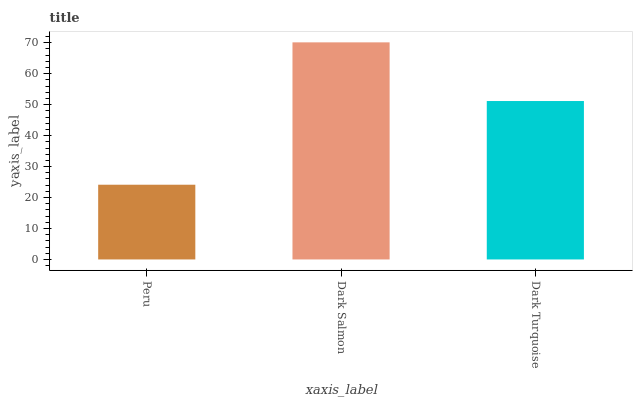Is Peru the minimum?
Answer yes or no. Yes. Is Dark Salmon the maximum?
Answer yes or no. Yes. Is Dark Turquoise the minimum?
Answer yes or no. No. Is Dark Turquoise the maximum?
Answer yes or no. No. Is Dark Salmon greater than Dark Turquoise?
Answer yes or no. Yes. Is Dark Turquoise less than Dark Salmon?
Answer yes or no. Yes. Is Dark Turquoise greater than Dark Salmon?
Answer yes or no. No. Is Dark Salmon less than Dark Turquoise?
Answer yes or no. No. Is Dark Turquoise the high median?
Answer yes or no. Yes. Is Dark Turquoise the low median?
Answer yes or no. Yes. Is Dark Salmon the high median?
Answer yes or no. No. Is Peru the low median?
Answer yes or no. No. 